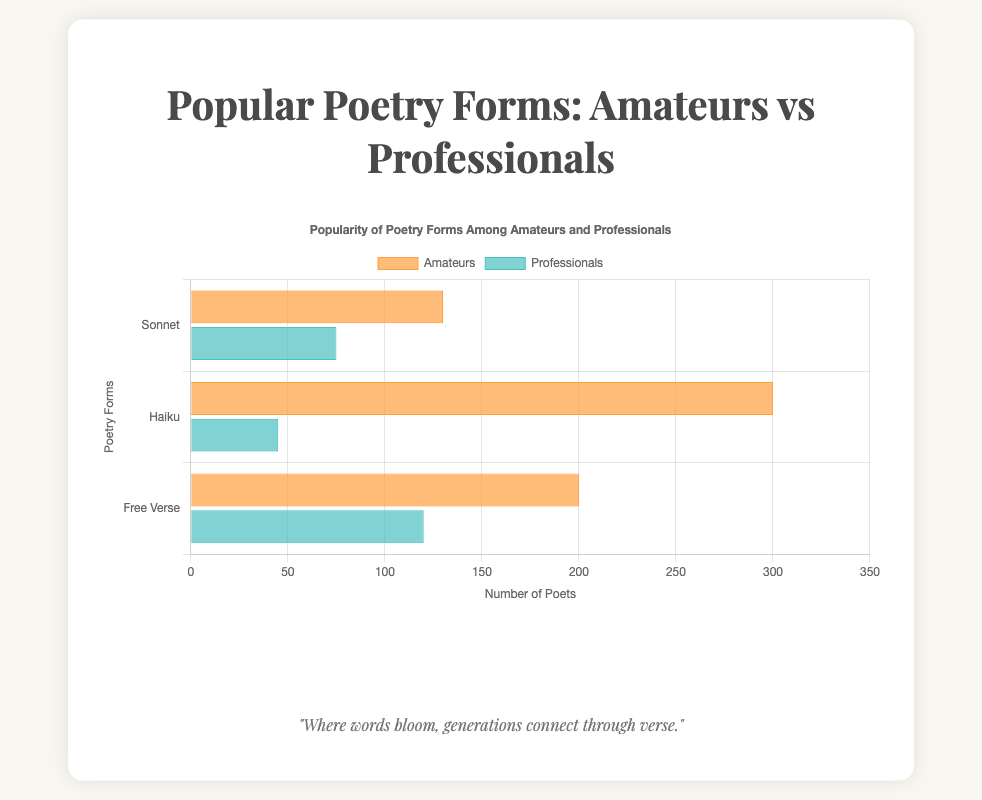Which poetry form has the highest number of amateur poets? By observing the lengths of the bars representing amateurs, it's clear that "Haiku" has the longest bar, indicating the highest number of amateur poets.
Answer: Haiku Which category writes more Sonnets, amateurs or professionals? By comparing the lengths of the bars for "Sonnet," the bar representing amateurs is longer than the bar for professionals, indicating more amateur sonnet writers.
Answer: Amateurs What is the total number of poets (both amateurs and professionals) writing Free Verse? Sum the values for both categories: 200 (amateurs) + 120 (professionals) = 320.
Answer: 320 How many more professional poets write Haiku compared to Free Verse? Subtract the number of professionals writing Haiku from those writing Free Verse: 120 (Free Verse) - 45 (Haiku) = 75.
Answer: 75 Which poetry form has the biggest discrepancy in popularity between amateurs and professionals? By observing the difference in bar lengths across categories for each form, Haiku shows the biggest difference: 300 (amateurs) - 45 (professionals) = 255.
Answer: Haiku What is the average number of poets (both amateurs and professionals) writing Sonnets? Sum the values for both categories and divide by 2: (130 + 75) / 2 = 102.5.
Answer: 102.5 Visually, which poetry form and category combination has the second longest bar? By visually comparing the lengths, the second longest bar belongs to amateurs writing Free Verse.
Answer: Amateurs writing Free Verse Compare the total number of amateur poets to professional poets across all poetry forms. Which group has more poets? Sum the values for amateurs and professionals separately. Amateurs: 130 (Sonnet) + 300 (Haiku) + 200 (Free Verse) = 630. Professionals: 75 (Sonnet) + 45 (Haiku) + 120 (Free Verse) = 240. Amateurs have more poets.
Answer: Amateurs What is the difference in the number of amateur poets writing Haiku and those writing Sonnets? Subtract the number of amateurs writing Sonnets from those writing Haiku: 300 (Haiku) - 130 (Sonnets) = 170.
Answer: 170 